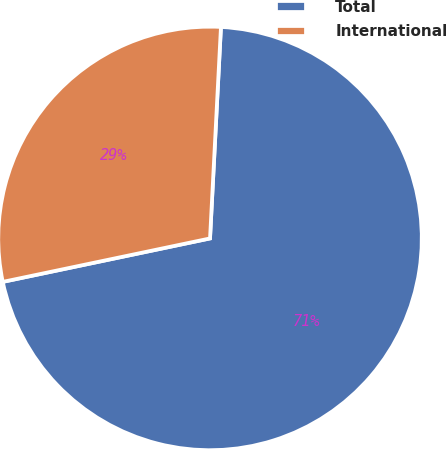Convert chart to OTSL. <chart><loc_0><loc_0><loc_500><loc_500><pie_chart><fcel>Total<fcel>International<nl><fcel>70.89%<fcel>29.11%<nl></chart> 